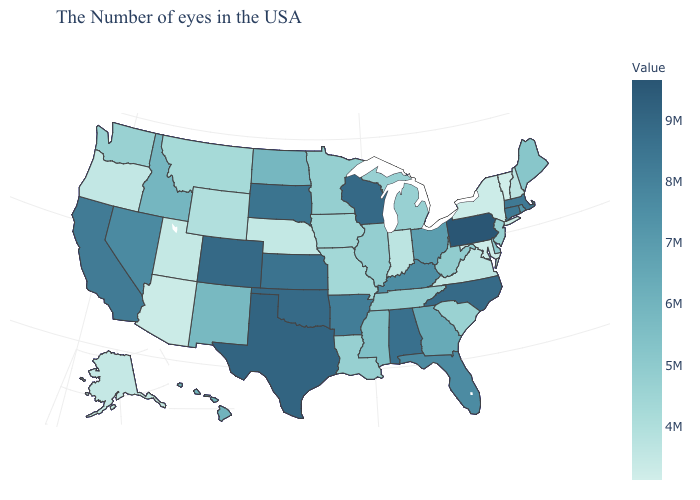Among the states that border North Carolina , does Virginia have the highest value?
Be succinct. No. Is the legend a continuous bar?
Short answer required. Yes. Does Vermont have the lowest value in the USA?
Write a very short answer. Yes. Which states have the highest value in the USA?
Short answer required. Pennsylvania. 